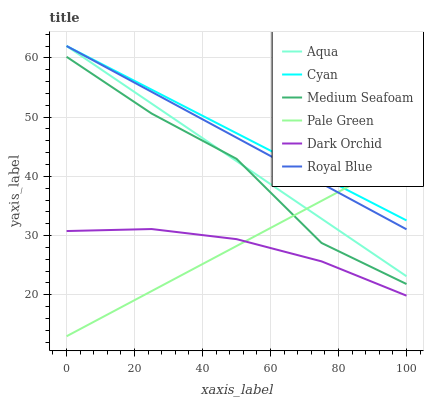Does Royal Blue have the minimum area under the curve?
Answer yes or no. No. Does Royal Blue have the maximum area under the curve?
Answer yes or no. No. Is Dark Orchid the smoothest?
Answer yes or no. No. Is Dark Orchid the roughest?
Answer yes or no. No. Does Dark Orchid have the lowest value?
Answer yes or no. No. Does Dark Orchid have the highest value?
Answer yes or no. No. Is Medium Seafoam less than Cyan?
Answer yes or no. Yes. Is Aqua greater than Dark Orchid?
Answer yes or no. Yes. Does Medium Seafoam intersect Cyan?
Answer yes or no. No. 